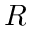<formula> <loc_0><loc_0><loc_500><loc_500>R</formula> 